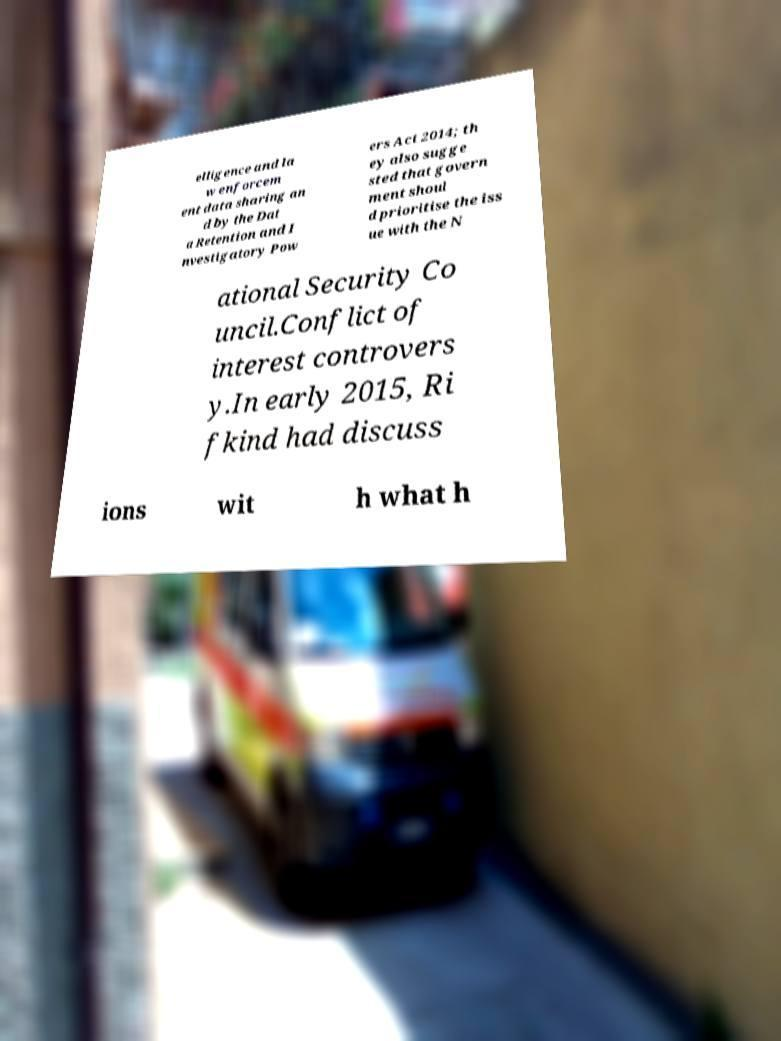What messages or text are displayed in this image? I need them in a readable, typed format. elligence and la w enforcem ent data sharing an d by the Dat a Retention and I nvestigatory Pow ers Act 2014; th ey also sugge sted that govern ment shoul d prioritise the iss ue with the N ational Security Co uncil.Conflict of interest controvers y.In early 2015, Ri fkind had discuss ions wit h what h 